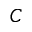Convert formula to latex. <formula><loc_0><loc_0><loc_500><loc_500>C</formula> 